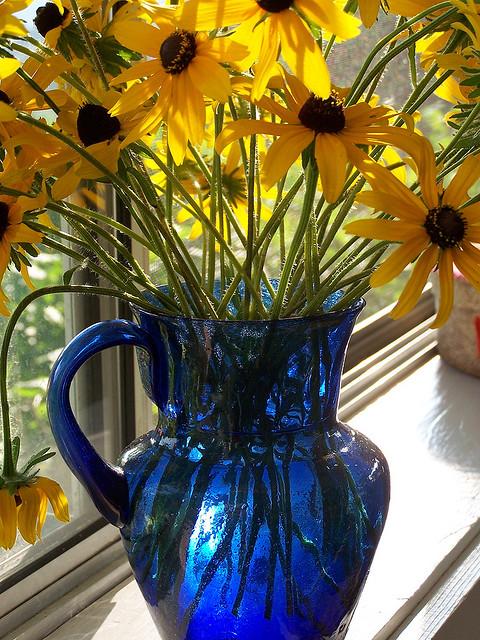Where is the vase sitting?
Give a very brief answer. Window sill. Is it time for the water to be changed?
Write a very short answer. No. What kind of flowers are these?
Be succinct. Daisies. What is the vase made of?
Write a very short answer. Glass. Is the vase on a table?
Give a very brief answer. No. 